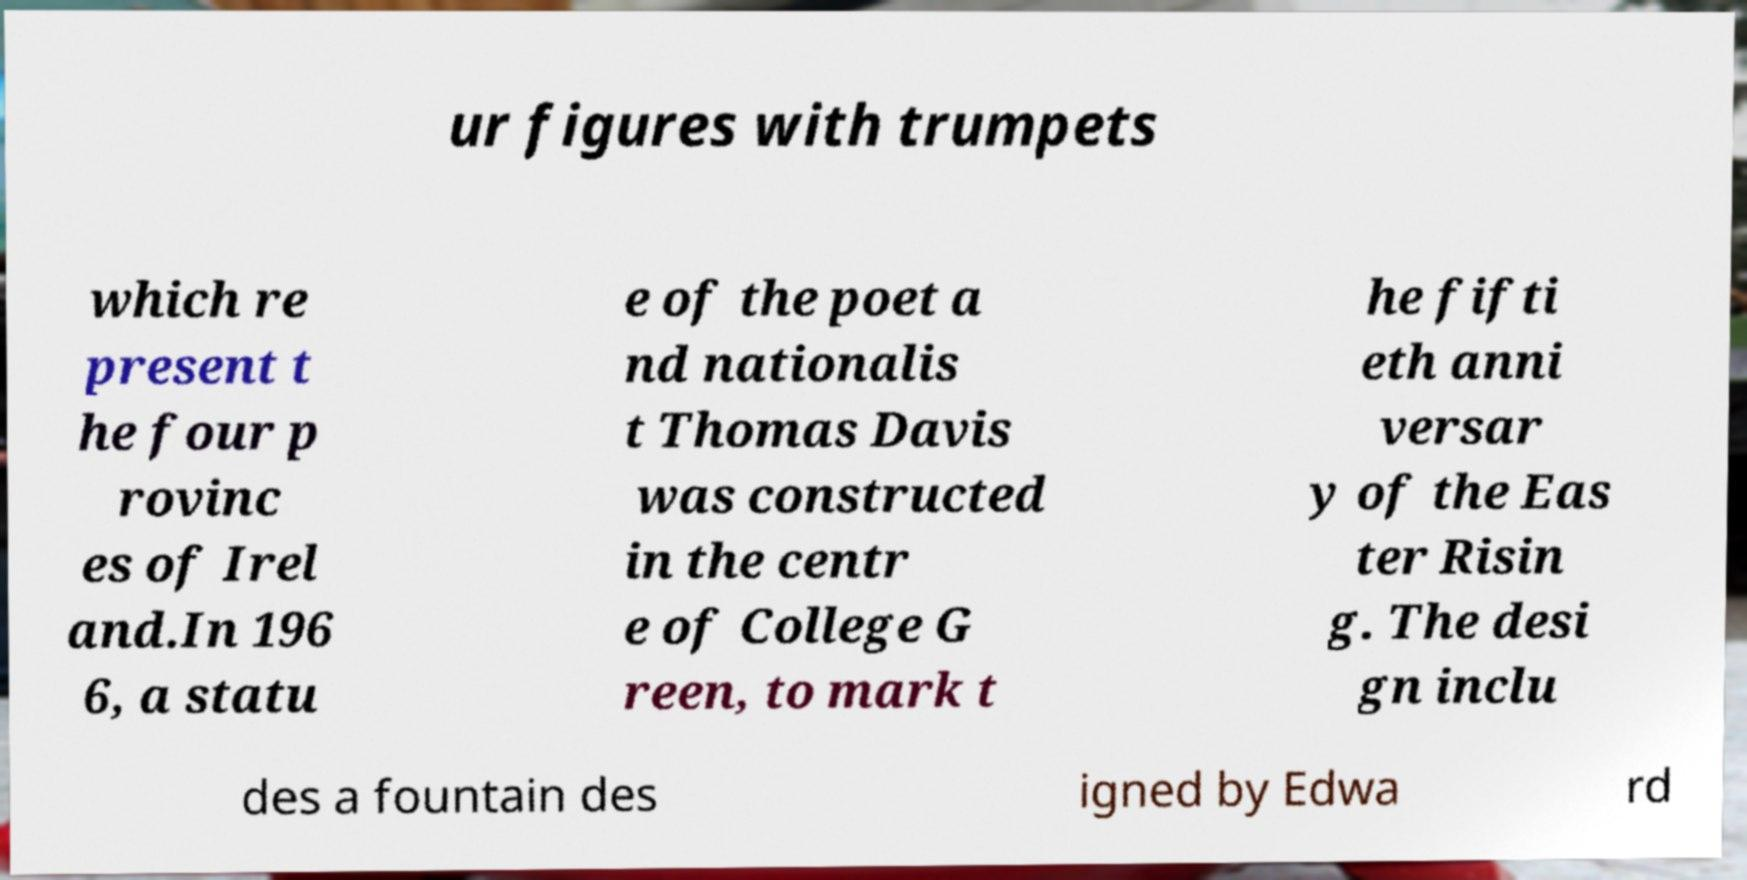Can you read and provide the text displayed in the image?This photo seems to have some interesting text. Can you extract and type it out for me? ur figures with trumpets which re present t he four p rovinc es of Irel and.In 196 6, a statu e of the poet a nd nationalis t Thomas Davis was constructed in the centr e of College G reen, to mark t he fifti eth anni versar y of the Eas ter Risin g. The desi gn inclu des a fountain des igned by Edwa rd 